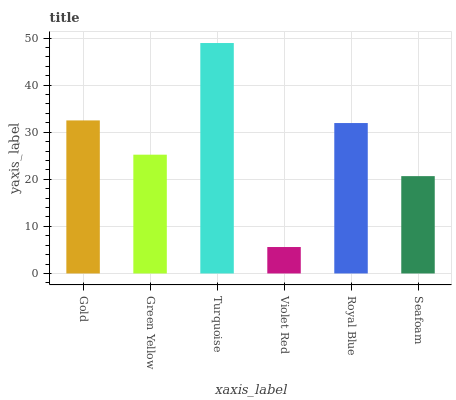Is Violet Red the minimum?
Answer yes or no. Yes. Is Turquoise the maximum?
Answer yes or no. Yes. Is Green Yellow the minimum?
Answer yes or no. No. Is Green Yellow the maximum?
Answer yes or no. No. Is Gold greater than Green Yellow?
Answer yes or no. Yes. Is Green Yellow less than Gold?
Answer yes or no. Yes. Is Green Yellow greater than Gold?
Answer yes or no. No. Is Gold less than Green Yellow?
Answer yes or no. No. Is Royal Blue the high median?
Answer yes or no. Yes. Is Green Yellow the low median?
Answer yes or no. Yes. Is Turquoise the high median?
Answer yes or no. No. Is Violet Red the low median?
Answer yes or no. No. 